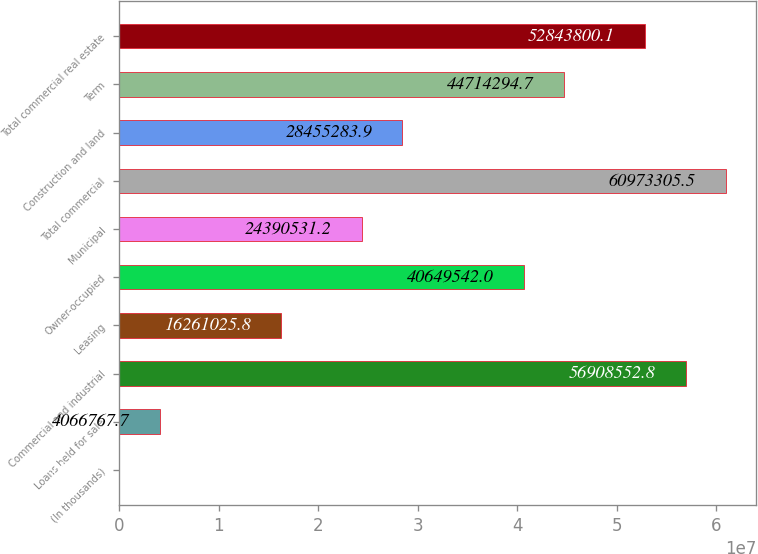Convert chart to OTSL. <chart><loc_0><loc_0><loc_500><loc_500><bar_chart><fcel>(In thousands)<fcel>Loans held for sale<fcel>Commercial and industrial<fcel>Leasing<fcel>Owner-occupied<fcel>Municipal<fcel>Total commercial<fcel>Construction and land<fcel>Term<fcel>Total commercial real estate<nl><fcel>2015<fcel>4.06677e+06<fcel>5.69086e+07<fcel>1.6261e+07<fcel>4.06495e+07<fcel>2.43905e+07<fcel>6.09733e+07<fcel>2.84553e+07<fcel>4.47143e+07<fcel>5.28438e+07<nl></chart> 